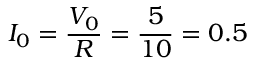<formula> <loc_0><loc_0><loc_500><loc_500>I _ { 0 } = \frac { V _ { 0 } } { R } = \frac { 5 } { 1 0 } = 0 . 5</formula> 